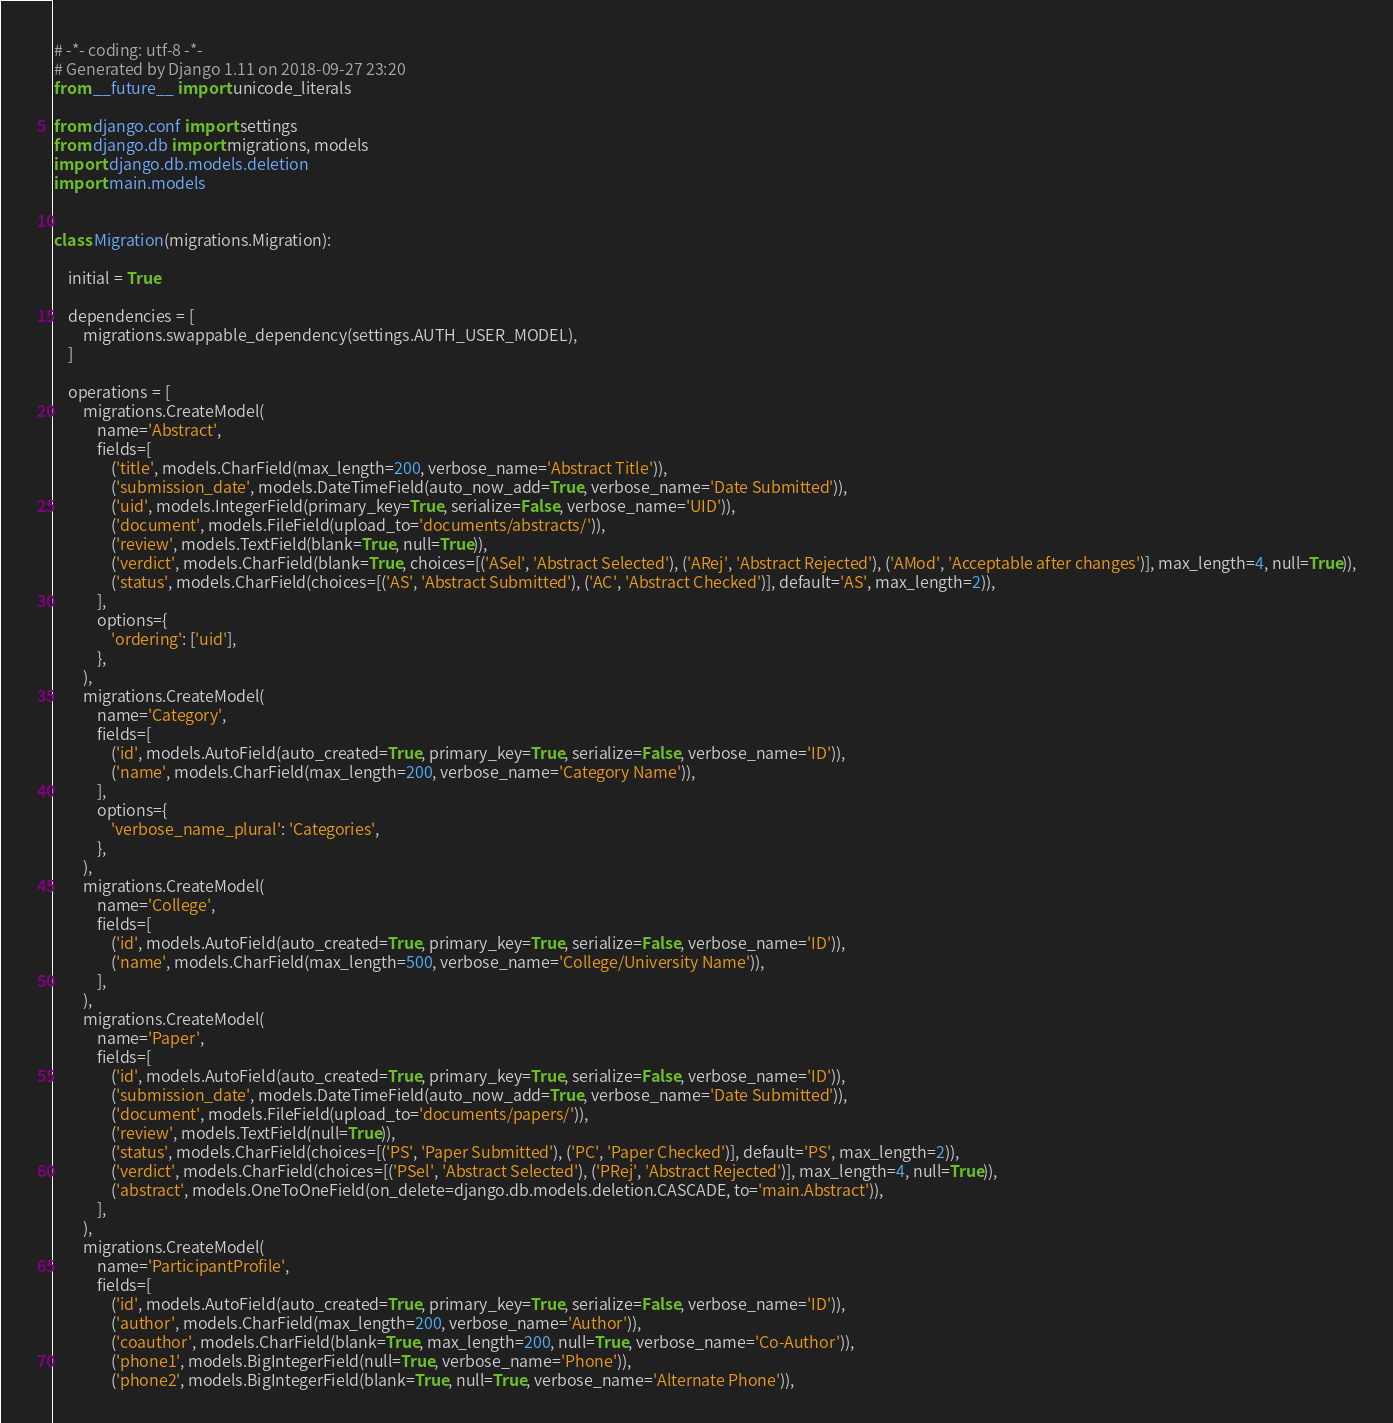<code> <loc_0><loc_0><loc_500><loc_500><_Python_># -*- coding: utf-8 -*-
# Generated by Django 1.11 on 2018-09-27 23:20
from __future__ import unicode_literals

from django.conf import settings
from django.db import migrations, models
import django.db.models.deletion
import main.models


class Migration(migrations.Migration):

    initial = True

    dependencies = [
        migrations.swappable_dependency(settings.AUTH_USER_MODEL),
    ]

    operations = [
        migrations.CreateModel(
            name='Abstract',
            fields=[
                ('title', models.CharField(max_length=200, verbose_name='Abstract Title')),
                ('submission_date', models.DateTimeField(auto_now_add=True, verbose_name='Date Submitted')),
                ('uid', models.IntegerField(primary_key=True, serialize=False, verbose_name='UID')),
                ('document', models.FileField(upload_to='documents/abstracts/')),
                ('review', models.TextField(blank=True, null=True)),
                ('verdict', models.CharField(blank=True, choices=[('ASel', 'Abstract Selected'), ('ARej', 'Abstract Rejected'), ('AMod', 'Acceptable after changes')], max_length=4, null=True)),
                ('status', models.CharField(choices=[('AS', 'Abstract Submitted'), ('AC', 'Abstract Checked')], default='AS', max_length=2)),
            ],
            options={
                'ordering': ['uid'],
            },
        ),
        migrations.CreateModel(
            name='Category',
            fields=[
                ('id', models.AutoField(auto_created=True, primary_key=True, serialize=False, verbose_name='ID')),
                ('name', models.CharField(max_length=200, verbose_name='Category Name')),
            ],
            options={
                'verbose_name_plural': 'Categories',
            },
        ),
        migrations.CreateModel(
            name='College',
            fields=[
                ('id', models.AutoField(auto_created=True, primary_key=True, serialize=False, verbose_name='ID')),
                ('name', models.CharField(max_length=500, verbose_name='College/University Name')),
            ],
        ),
        migrations.CreateModel(
            name='Paper',
            fields=[
                ('id', models.AutoField(auto_created=True, primary_key=True, serialize=False, verbose_name='ID')),
                ('submission_date', models.DateTimeField(auto_now_add=True, verbose_name='Date Submitted')),
                ('document', models.FileField(upload_to='documents/papers/')),
                ('review', models.TextField(null=True)),
                ('status', models.CharField(choices=[('PS', 'Paper Submitted'), ('PC', 'Paper Checked')], default='PS', max_length=2)),
                ('verdict', models.CharField(choices=[('PSel', 'Abstract Selected'), ('PRej', 'Abstract Rejected')], max_length=4, null=True)),
                ('abstract', models.OneToOneField(on_delete=django.db.models.deletion.CASCADE, to='main.Abstract')),
            ],
        ),
        migrations.CreateModel(
            name='ParticipantProfile',
            fields=[
                ('id', models.AutoField(auto_created=True, primary_key=True, serialize=False, verbose_name='ID')),
                ('author', models.CharField(max_length=200, verbose_name='Author')),
                ('coauthor', models.CharField(blank=True, max_length=200, null=True, verbose_name='Co-Author')),
                ('phone1', models.BigIntegerField(null=True, verbose_name='Phone')),
                ('phone2', models.BigIntegerField(blank=True, null=True, verbose_name='Alternate Phone')),</code> 